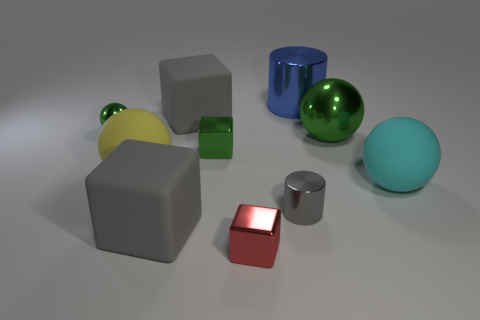Subtract all cubes. How many objects are left? 6 Subtract 0 gray spheres. How many objects are left? 10 Subtract all brown cylinders. Subtract all gray matte cubes. How many objects are left? 8 Add 8 cyan rubber balls. How many cyan rubber balls are left? 9 Add 3 yellow matte things. How many yellow matte things exist? 4 